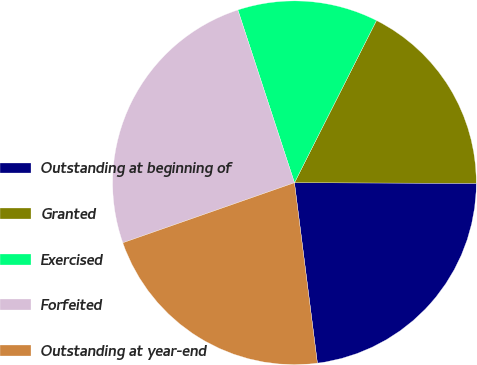<chart> <loc_0><loc_0><loc_500><loc_500><pie_chart><fcel>Outstanding at beginning of<fcel>Granted<fcel>Exercised<fcel>Forfeited<fcel>Outstanding at year-end<nl><fcel>22.94%<fcel>17.6%<fcel>12.49%<fcel>25.32%<fcel>21.66%<nl></chart> 